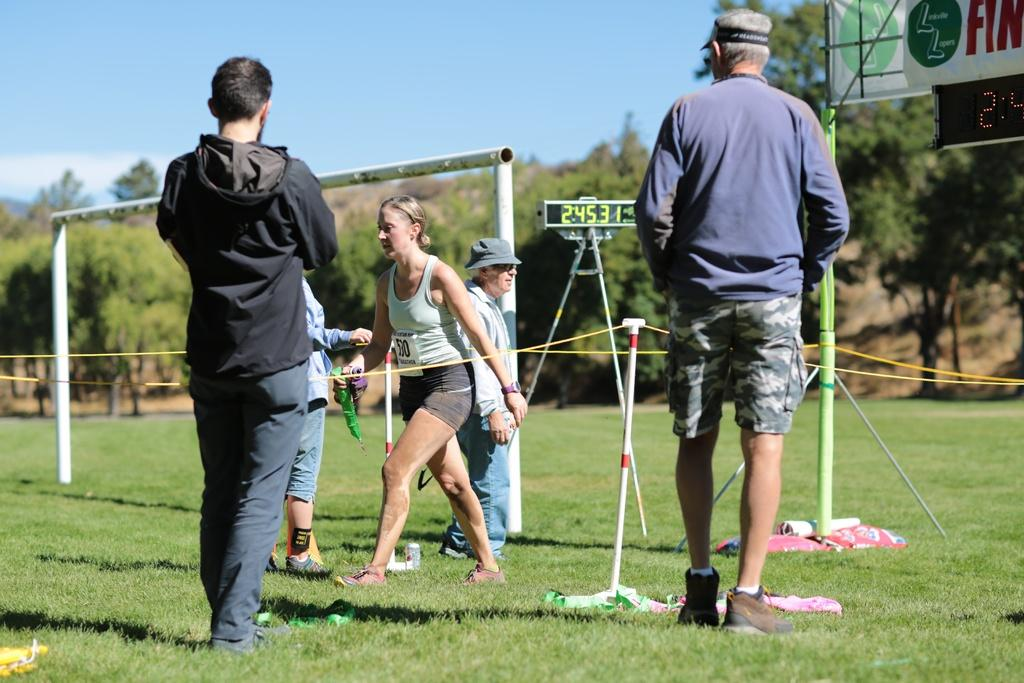<image>
Provide a brief description of the given image. Several people in a field of a sporting event with a scoreboard with the numbers 24531 litup 